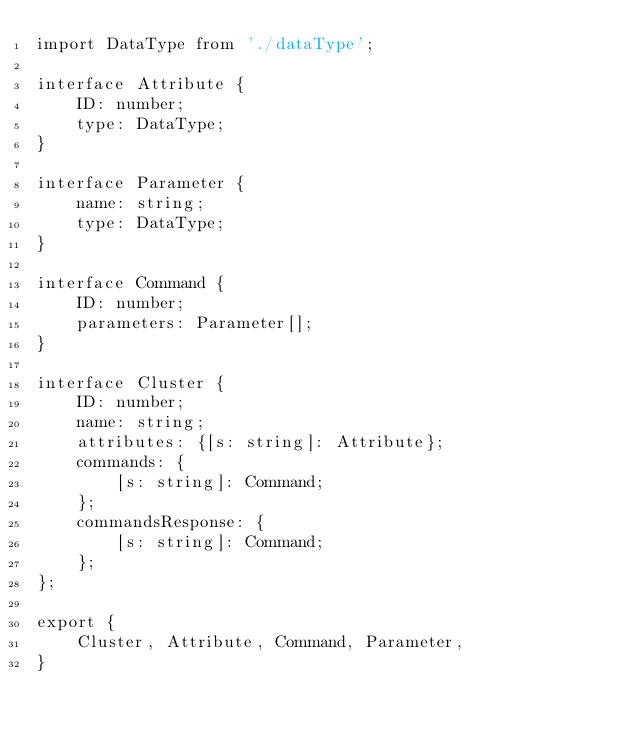<code> <loc_0><loc_0><loc_500><loc_500><_TypeScript_>import DataType from './dataType';

interface Attribute {
    ID: number;
    type: DataType;
}

interface Parameter {
    name: string;
    type: DataType;
}

interface Command {
    ID: number;
    parameters: Parameter[];
}

interface Cluster {
    ID: number;
    name: string;
    attributes: {[s: string]: Attribute};
    commands: {
        [s: string]: Command;
    };
    commandsResponse: {
        [s: string]: Command;
    };
};

export {
    Cluster, Attribute, Command, Parameter,
}</code> 